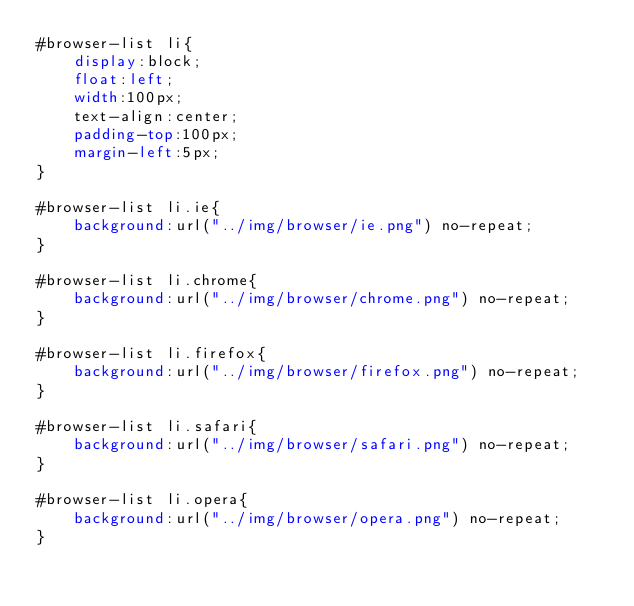Convert code to text. <code><loc_0><loc_0><loc_500><loc_500><_CSS_>#browser-list li{
    display:block;
    float:left; 
    width:100px;
    text-align:center;
    padding-top:100px;
    margin-left:5px;
}

#browser-list li.ie{
    background:url("../img/browser/ie.png") no-repeat;
}

#browser-list li.chrome{
    background:url("../img/browser/chrome.png") no-repeat;
}

#browser-list li.firefox{
    background:url("../img/browser/firefox.png") no-repeat;
}

#browser-list li.safari{
    background:url("../img/browser/safari.png") no-repeat;
}

#browser-list li.opera{
    background:url("../img/browser/opera.png") no-repeat;
}

</code> 